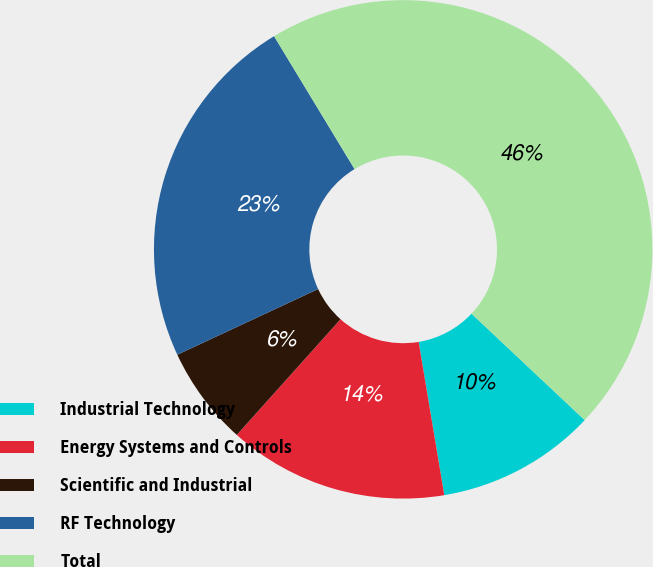Convert chart. <chart><loc_0><loc_0><loc_500><loc_500><pie_chart><fcel>Industrial Technology<fcel>Energy Systems and Controls<fcel>Scientific and Industrial<fcel>RF Technology<fcel>Total<nl><fcel>10.35%<fcel>14.27%<fcel>6.42%<fcel>23.28%<fcel>45.68%<nl></chart> 